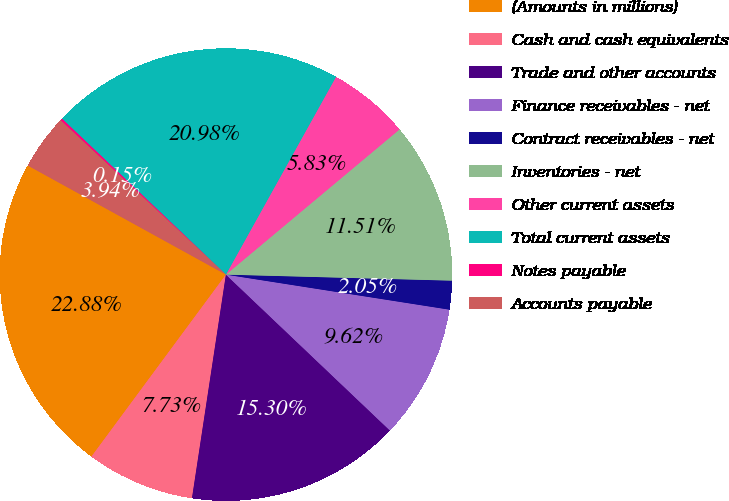Convert chart. <chart><loc_0><loc_0><loc_500><loc_500><pie_chart><fcel>(Amounts in millions)<fcel>Cash and cash equivalents<fcel>Trade and other accounts<fcel>Finance receivables - net<fcel>Contract receivables - net<fcel>Inventories - net<fcel>Other current assets<fcel>Total current assets<fcel>Notes payable<fcel>Accounts payable<nl><fcel>22.88%<fcel>7.73%<fcel>15.3%<fcel>9.62%<fcel>2.05%<fcel>11.51%<fcel>5.83%<fcel>20.98%<fcel>0.15%<fcel>3.94%<nl></chart> 